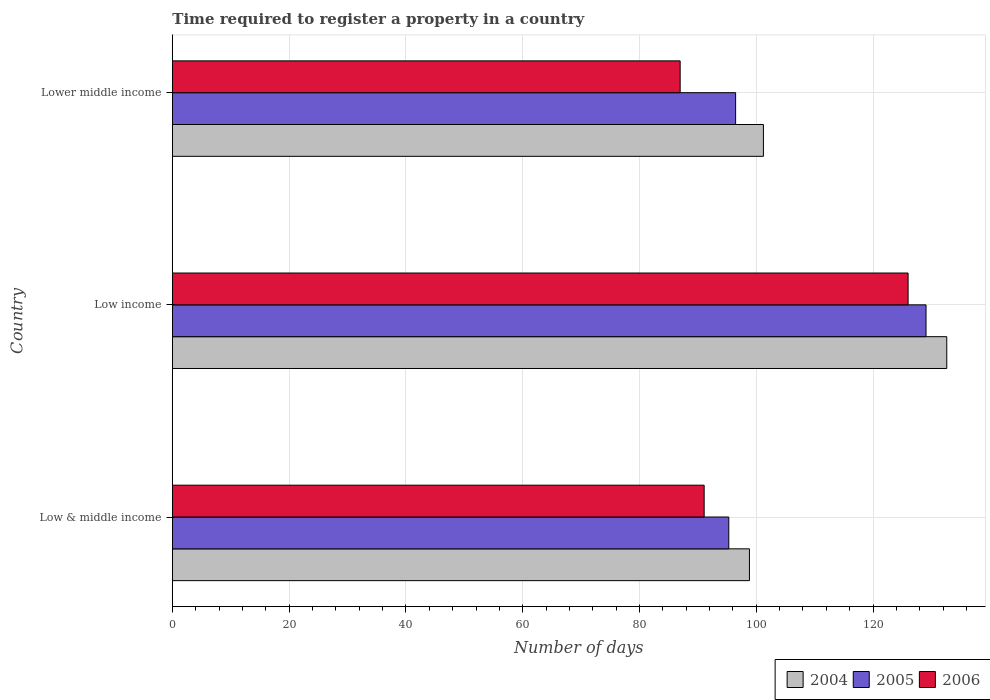How many groups of bars are there?
Give a very brief answer. 3. Are the number of bars per tick equal to the number of legend labels?
Ensure brevity in your answer.  Yes. How many bars are there on the 1st tick from the top?
Provide a succinct answer. 3. What is the label of the 2nd group of bars from the top?
Offer a terse response. Low income. What is the number of days required to register a property in 2006 in Low income?
Offer a terse response. 126. Across all countries, what is the maximum number of days required to register a property in 2006?
Ensure brevity in your answer.  126. Across all countries, what is the minimum number of days required to register a property in 2005?
Your answer should be very brief. 95.29. In which country was the number of days required to register a property in 2006 maximum?
Keep it short and to the point. Low income. In which country was the number of days required to register a property in 2004 minimum?
Your response must be concise. Low & middle income. What is the total number of days required to register a property in 2004 in the graph?
Offer a very short reply. 332.68. What is the difference between the number of days required to register a property in 2006 in Low & middle income and that in Lower middle income?
Provide a short and direct response. 4.11. What is the difference between the number of days required to register a property in 2006 in Lower middle income and the number of days required to register a property in 2004 in Low income?
Ensure brevity in your answer.  -45.66. What is the average number of days required to register a property in 2006 per country?
Offer a terse response. 101.35. What is the difference between the number of days required to register a property in 2004 and number of days required to register a property in 2006 in Lower middle income?
Provide a succinct answer. 14.26. What is the ratio of the number of days required to register a property in 2004 in Low & middle income to that in Low income?
Keep it short and to the point. 0.75. Is the difference between the number of days required to register a property in 2004 in Low income and Lower middle income greater than the difference between the number of days required to register a property in 2006 in Low income and Lower middle income?
Keep it short and to the point. No. What is the difference between the highest and the second highest number of days required to register a property in 2006?
Ensure brevity in your answer.  34.92. What is the difference between the highest and the lowest number of days required to register a property in 2005?
Give a very brief answer. 33.78. What does the 1st bar from the top in Low & middle income represents?
Your response must be concise. 2006. How many bars are there?
Ensure brevity in your answer.  9. How many countries are there in the graph?
Ensure brevity in your answer.  3. Does the graph contain any zero values?
Give a very brief answer. No. How are the legend labels stacked?
Provide a succinct answer. Horizontal. What is the title of the graph?
Offer a very short reply. Time required to register a property in a country. Does "1979" appear as one of the legend labels in the graph?
Give a very brief answer. No. What is the label or title of the X-axis?
Keep it short and to the point. Number of days. What is the label or title of the Y-axis?
Provide a succinct answer. Country. What is the Number of days of 2004 in Low & middle income?
Your answer should be compact. 98.83. What is the Number of days of 2005 in Low & middle income?
Offer a terse response. 95.29. What is the Number of days of 2006 in Low & middle income?
Keep it short and to the point. 91.08. What is the Number of days in 2004 in Low income?
Provide a short and direct response. 132.62. What is the Number of days of 2005 in Low income?
Ensure brevity in your answer.  129.07. What is the Number of days in 2006 in Low income?
Provide a succinct answer. 126. What is the Number of days in 2004 in Lower middle income?
Ensure brevity in your answer.  101.22. What is the Number of days in 2005 in Lower middle income?
Ensure brevity in your answer.  96.46. What is the Number of days in 2006 in Lower middle income?
Your response must be concise. 86.96. Across all countries, what is the maximum Number of days in 2004?
Provide a short and direct response. 132.62. Across all countries, what is the maximum Number of days of 2005?
Keep it short and to the point. 129.07. Across all countries, what is the maximum Number of days in 2006?
Your response must be concise. 126. Across all countries, what is the minimum Number of days in 2004?
Your answer should be very brief. 98.83. Across all countries, what is the minimum Number of days in 2005?
Make the answer very short. 95.29. Across all countries, what is the minimum Number of days in 2006?
Keep it short and to the point. 86.96. What is the total Number of days of 2004 in the graph?
Your answer should be compact. 332.68. What is the total Number of days in 2005 in the graph?
Make the answer very short. 320.83. What is the total Number of days in 2006 in the graph?
Make the answer very short. 304.04. What is the difference between the Number of days of 2004 in Low & middle income and that in Low income?
Provide a succinct answer. -33.8. What is the difference between the Number of days in 2005 in Low & middle income and that in Low income?
Provide a succinct answer. -33.78. What is the difference between the Number of days of 2006 in Low & middle income and that in Low income?
Your response must be concise. -34.92. What is the difference between the Number of days of 2004 in Low & middle income and that in Lower middle income?
Provide a short and direct response. -2.39. What is the difference between the Number of days of 2005 in Low & middle income and that in Lower middle income?
Offer a terse response. -1.17. What is the difference between the Number of days of 2006 in Low & middle income and that in Lower middle income?
Provide a succinct answer. 4.11. What is the difference between the Number of days of 2004 in Low income and that in Lower middle income?
Offer a very short reply. 31.4. What is the difference between the Number of days in 2005 in Low income and that in Lower middle income?
Ensure brevity in your answer.  32.61. What is the difference between the Number of days of 2006 in Low income and that in Lower middle income?
Make the answer very short. 39.04. What is the difference between the Number of days in 2004 in Low & middle income and the Number of days in 2005 in Low income?
Your answer should be very brief. -30.24. What is the difference between the Number of days of 2004 in Low & middle income and the Number of days of 2006 in Low income?
Keep it short and to the point. -27.17. What is the difference between the Number of days in 2005 in Low & middle income and the Number of days in 2006 in Low income?
Offer a very short reply. -30.71. What is the difference between the Number of days of 2004 in Low & middle income and the Number of days of 2005 in Lower middle income?
Make the answer very short. 2.37. What is the difference between the Number of days of 2004 in Low & middle income and the Number of days of 2006 in Lower middle income?
Your response must be concise. 11.87. What is the difference between the Number of days of 2005 in Low & middle income and the Number of days of 2006 in Lower middle income?
Provide a succinct answer. 8.33. What is the difference between the Number of days in 2004 in Low income and the Number of days in 2005 in Lower middle income?
Offer a very short reply. 36.16. What is the difference between the Number of days in 2004 in Low income and the Number of days in 2006 in Lower middle income?
Your answer should be very brief. 45.66. What is the difference between the Number of days of 2005 in Low income and the Number of days of 2006 in Lower middle income?
Make the answer very short. 42.11. What is the average Number of days of 2004 per country?
Give a very brief answer. 110.89. What is the average Number of days of 2005 per country?
Provide a succinct answer. 106.94. What is the average Number of days of 2006 per country?
Offer a very short reply. 101.35. What is the difference between the Number of days in 2004 and Number of days in 2005 in Low & middle income?
Give a very brief answer. 3.54. What is the difference between the Number of days of 2004 and Number of days of 2006 in Low & middle income?
Offer a very short reply. 7.75. What is the difference between the Number of days in 2005 and Number of days in 2006 in Low & middle income?
Provide a short and direct response. 4.22. What is the difference between the Number of days of 2004 and Number of days of 2005 in Low income?
Your answer should be compact. 3.55. What is the difference between the Number of days of 2004 and Number of days of 2006 in Low income?
Provide a short and direct response. 6.62. What is the difference between the Number of days in 2005 and Number of days in 2006 in Low income?
Make the answer very short. 3.07. What is the difference between the Number of days of 2004 and Number of days of 2005 in Lower middle income?
Provide a succinct answer. 4.76. What is the difference between the Number of days of 2004 and Number of days of 2006 in Lower middle income?
Keep it short and to the point. 14.26. What is the ratio of the Number of days of 2004 in Low & middle income to that in Low income?
Make the answer very short. 0.75. What is the ratio of the Number of days of 2005 in Low & middle income to that in Low income?
Your answer should be very brief. 0.74. What is the ratio of the Number of days of 2006 in Low & middle income to that in Low income?
Ensure brevity in your answer.  0.72. What is the ratio of the Number of days in 2004 in Low & middle income to that in Lower middle income?
Your response must be concise. 0.98. What is the ratio of the Number of days of 2005 in Low & middle income to that in Lower middle income?
Offer a terse response. 0.99. What is the ratio of the Number of days in 2006 in Low & middle income to that in Lower middle income?
Your response must be concise. 1.05. What is the ratio of the Number of days in 2004 in Low income to that in Lower middle income?
Provide a succinct answer. 1.31. What is the ratio of the Number of days in 2005 in Low income to that in Lower middle income?
Your answer should be compact. 1.34. What is the ratio of the Number of days of 2006 in Low income to that in Lower middle income?
Your answer should be very brief. 1.45. What is the difference between the highest and the second highest Number of days in 2004?
Make the answer very short. 31.4. What is the difference between the highest and the second highest Number of days of 2005?
Ensure brevity in your answer.  32.61. What is the difference between the highest and the second highest Number of days of 2006?
Provide a succinct answer. 34.92. What is the difference between the highest and the lowest Number of days of 2004?
Your answer should be very brief. 33.8. What is the difference between the highest and the lowest Number of days of 2005?
Your response must be concise. 33.78. What is the difference between the highest and the lowest Number of days of 2006?
Give a very brief answer. 39.04. 